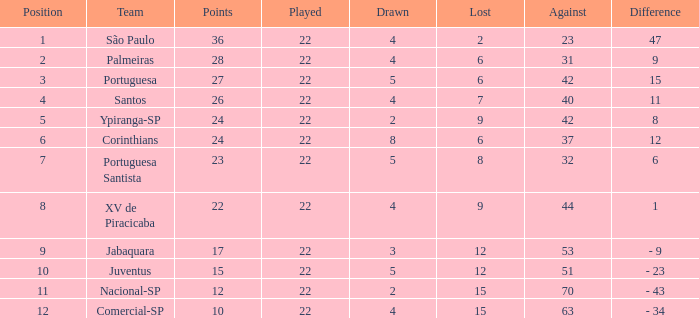Which Played has a Lost larger than 9, and a Points smaller than 15, and a Position smaller than 12, and a Drawn smaller than 2? None. 